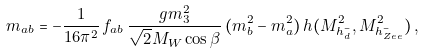<formula> <loc_0><loc_0><loc_500><loc_500>m _ { a b } = - \frac { 1 } { 1 6 \pi ^ { 2 } } \, f _ { a b } \, \frac { g m _ { 3 } ^ { 2 } } { \sqrt { 2 } M _ { W } \cos \beta } \, ( m _ { b } ^ { 2 } - m _ { a } ^ { 2 } ) \, h ( M _ { h _ { d } ^ { - } } ^ { 2 } , M _ { h _ { Z e e } ^ { - } } ^ { 2 } ) \, ,</formula> 